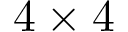Convert formula to latex. <formula><loc_0><loc_0><loc_500><loc_500>4 \times 4</formula> 